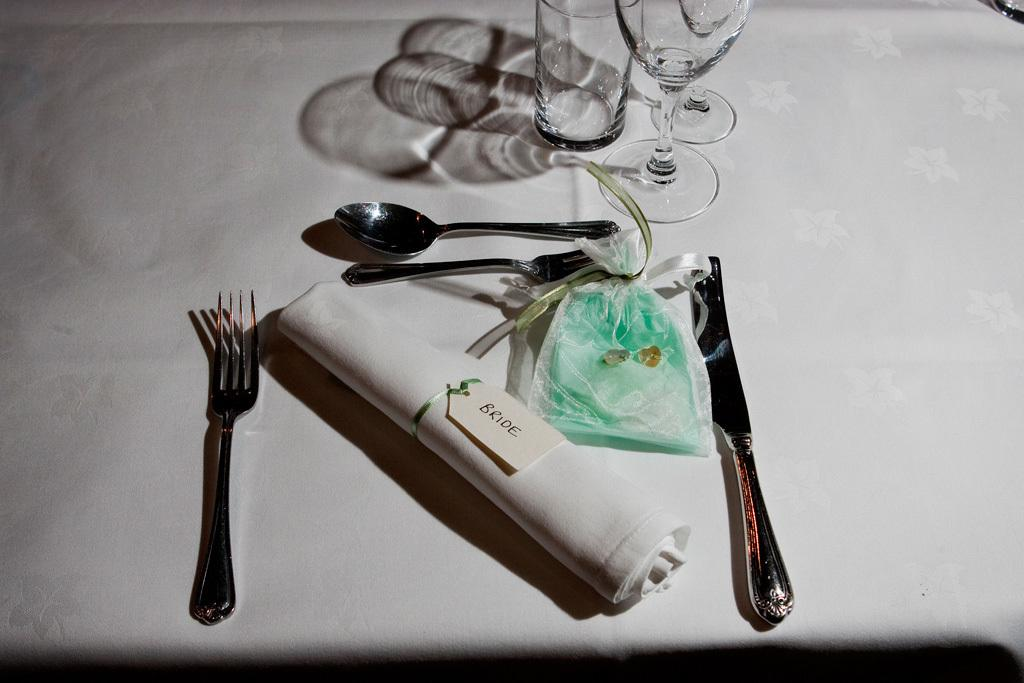What piece of furniture is present in the image? There is a table in the image. What items can be seen on the table? There are glasses, spoons, forks, and knives on the table. Is there any covering or material on the table? Yes, there is a cloth on the table. What type of hair can be seen on the table in the image? There is no hair present on the table in the image. What kind of camera is visible on the table in the image? There is no camera present on the table in the image. 